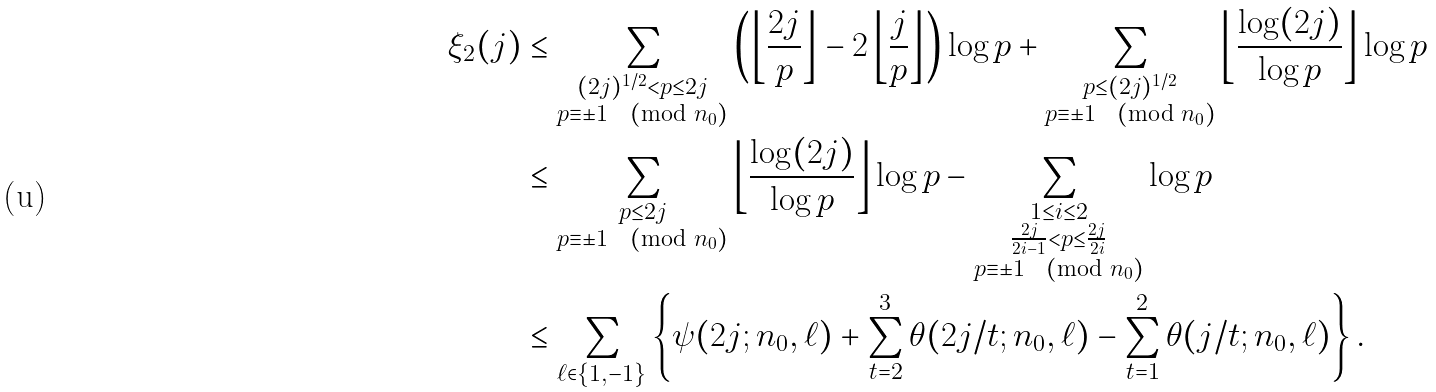<formula> <loc_0><loc_0><loc_500><loc_500>\xi _ { 2 } ( j ) & \leq \sum _ { \substack { ( 2 j ) ^ { 1 / 2 } < p \leq 2 j \\ p \equiv \pm 1 \pmod { n _ { 0 } } } } \left ( \left \lfloor \frac { 2 j } { p } \right \rfloor - 2 \left \lfloor \frac { j } { p } \right \rfloor \right ) \log p + \sum _ { \substack { p \leq ( 2 j ) ^ { 1 / 2 } \\ p \equiv \pm 1 \pmod { n _ { 0 } } } } \left \lfloor \frac { \log ( 2 j ) } { \log p } \right \rfloor \log p \\ & \leq \sum _ { \substack { p \leq 2 j \\ p \equiv \pm 1 \pmod { n _ { 0 } } } } \left \lfloor \frac { \log ( 2 j ) } { \log p } \right \rfloor \log p - \sum _ { \substack { 1 \leq i \leq 2 \\ \frac { 2 j } { 2 i - 1 } < p \leq \frac { 2 j } { 2 i } \\ p \equiv \pm 1 \pmod { n _ { 0 } } } } \log p \\ & \leq \sum _ { \ell \in \{ 1 , - 1 \} } \left \{ \psi ( 2 j ; n _ { 0 } , \ell ) + \sum ^ { 3 } _ { t = 2 } \theta ( 2 j / t ; n _ { 0 } , \ell ) - \sum ^ { 2 } _ { t = 1 } \theta ( j / t ; n _ { 0 } , \ell ) \right \} .</formula> 